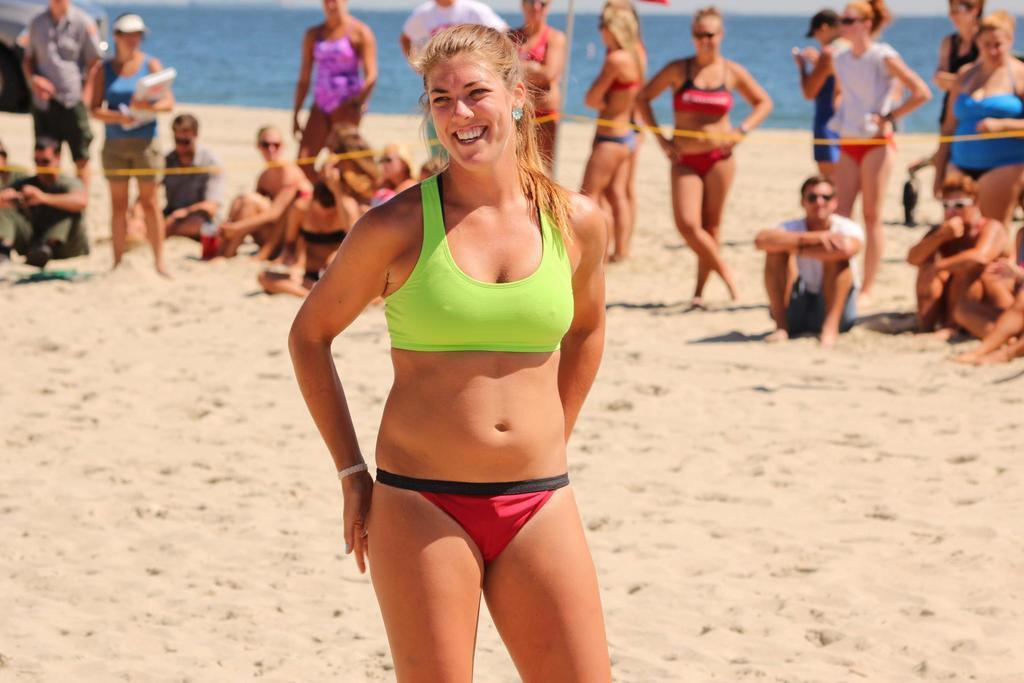What is the main subject of the image? There is a woman standing in the image. Are there any other people in the image? Yes, there are people standing in the image. What are some of the people in the image doing? Some people are sitting in the sand in the image. What can be seen in the background of the image? There is water visible in the image. What type of polish is being applied to the wire in the image? There is no polish or wire present in the image. What is the rate of the waves in the water visible in the image? The provided facts do not mention any waves in the water, so it is impossible to determine the rate of the waves. 